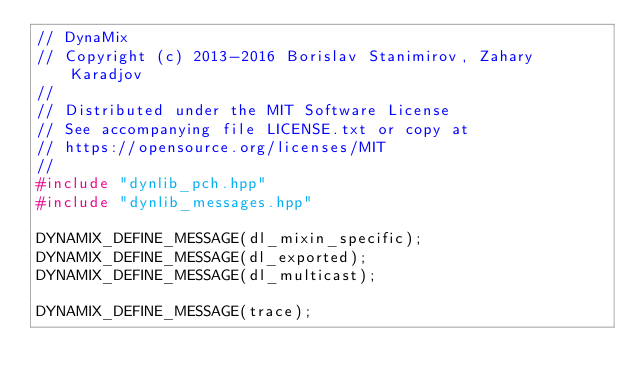Convert code to text. <code><loc_0><loc_0><loc_500><loc_500><_C++_>// DynaMix
// Copyright (c) 2013-2016 Borislav Stanimirov, Zahary Karadjov
//
// Distributed under the MIT Software License
// See accompanying file LICENSE.txt or copy at
// https://opensource.org/licenses/MIT
//
#include "dynlib_pch.hpp"
#include "dynlib_messages.hpp"

DYNAMIX_DEFINE_MESSAGE(dl_mixin_specific);
DYNAMIX_DEFINE_MESSAGE(dl_exported);
DYNAMIX_DEFINE_MESSAGE(dl_multicast);

DYNAMIX_DEFINE_MESSAGE(trace);
</code> 